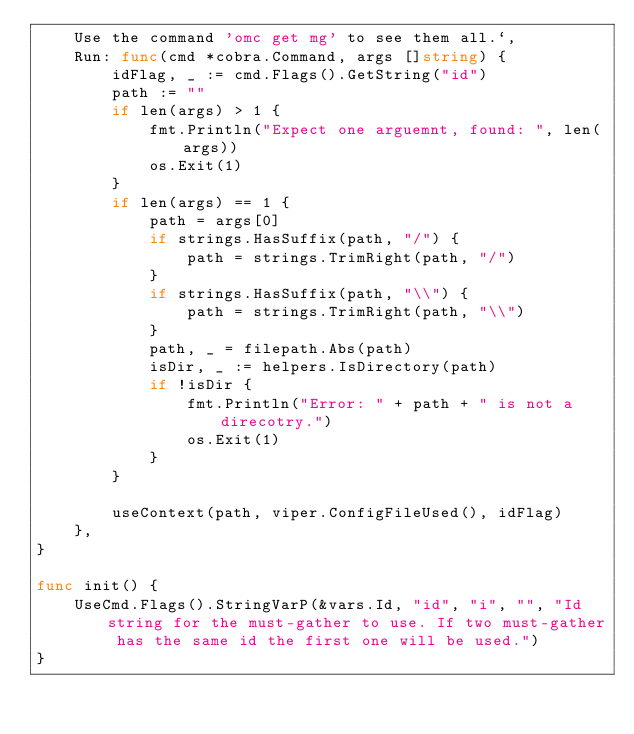Convert code to text. <code><loc_0><loc_0><loc_500><loc_500><_Go_>	Use the command 'omc get mg' to see them all.`,
	Run: func(cmd *cobra.Command, args []string) {
		idFlag, _ := cmd.Flags().GetString("id")
		path := ""
		if len(args) > 1 {
			fmt.Println("Expect one arguemnt, found: ", len(args))
			os.Exit(1)
		}
		if len(args) == 1 {
			path = args[0]
			if strings.HasSuffix(path, "/") {
				path = strings.TrimRight(path, "/")
			}
			if strings.HasSuffix(path, "\\") {
				path = strings.TrimRight(path, "\\")
			}
			path, _ = filepath.Abs(path)
			isDir, _ := helpers.IsDirectory(path)
			if !isDir {
				fmt.Println("Error: " + path + " is not a direcotry.")
				os.Exit(1)
			}
		}

		useContext(path, viper.ConfigFileUsed(), idFlag)
	},
}

func init() {
	UseCmd.Flags().StringVarP(&vars.Id, "id", "i", "", "Id string for the must-gather to use. If two must-gather has the same id the first one will be used.")
}
</code> 